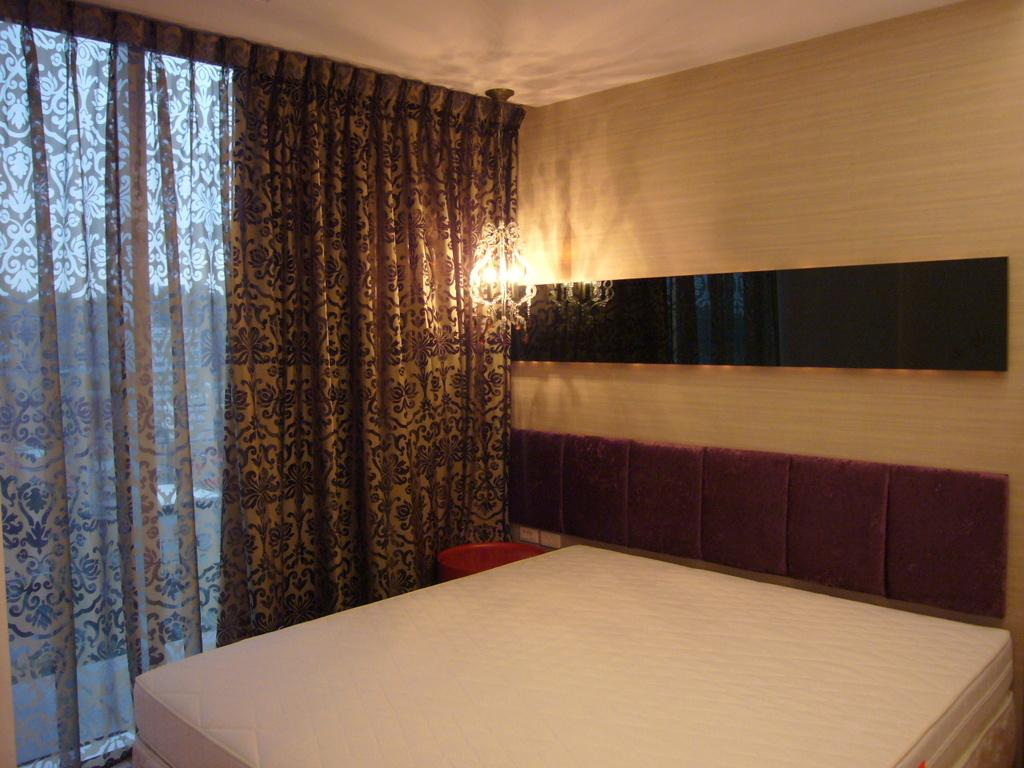What type of furniture is present in the image? There is a white bed in the image. What color is the cushion in the image? There is a brown cushion in the image. What material is used for the wall in the image? There is a wooden panel wall in the image. What type of window treatment is present in the image? There is a brown curtain in the image. What type of lighting is present in the image? There is a table light in the image. What type of plane can be seen flying through the sheet in the image? There is no plane or sheet present in the image; it is an indoor setting with a white bed, brown cushion, wooden panel wall, brown curtain, and table light. 